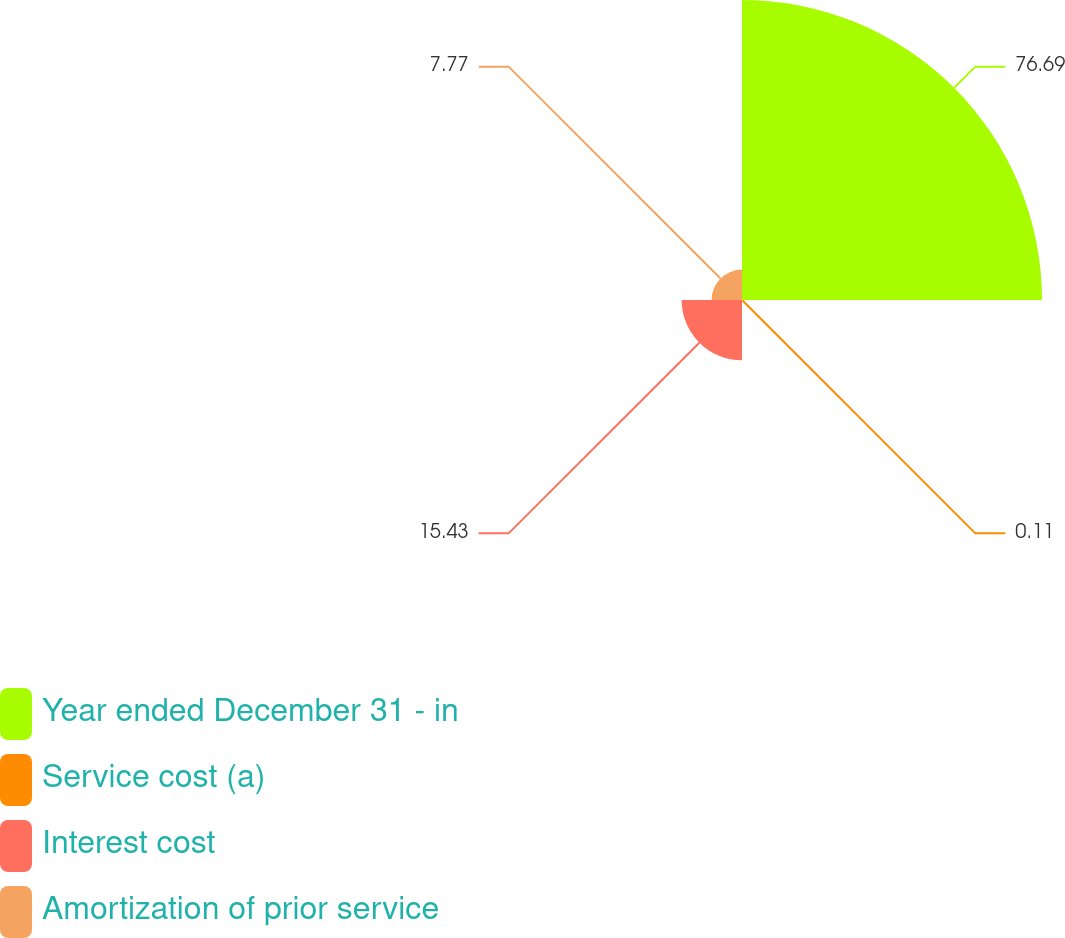<chart> <loc_0><loc_0><loc_500><loc_500><pie_chart><fcel>Year ended December 31 - in<fcel>Service cost (a)<fcel>Interest cost<fcel>Amortization of prior service<nl><fcel>76.69%<fcel>0.11%<fcel>15.43%<fcel>7.77%<nl></chart> 